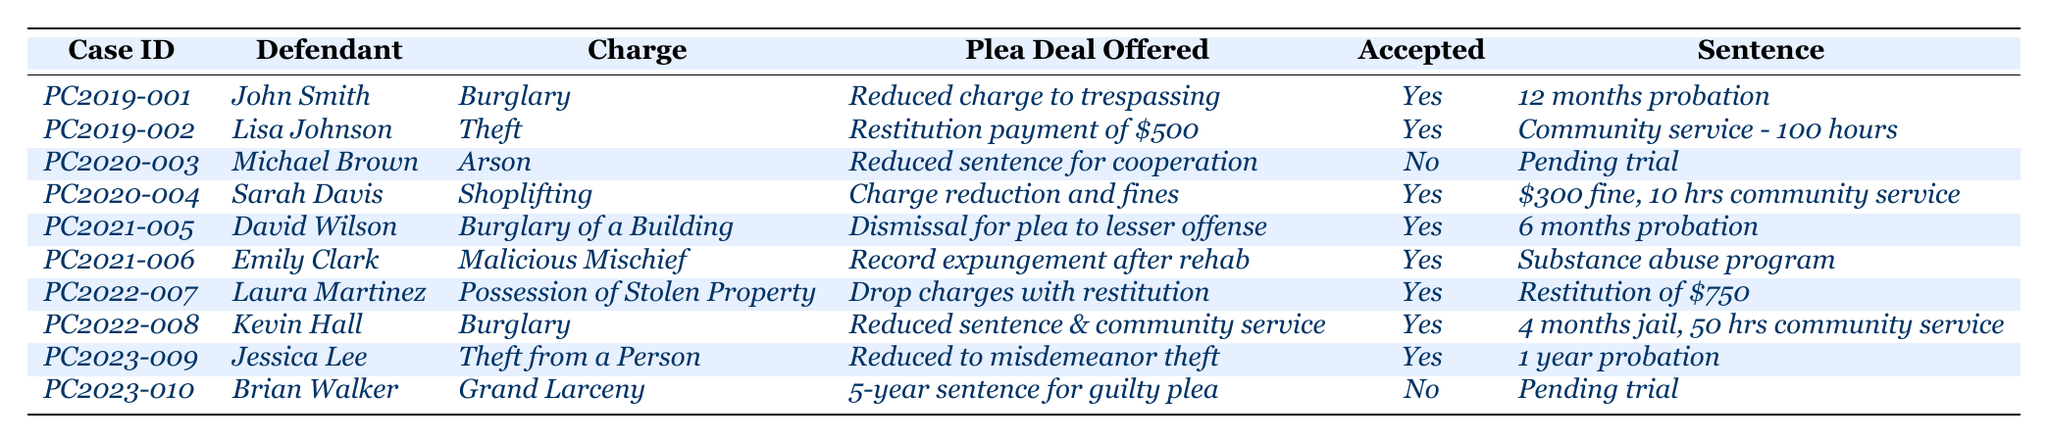What was the plea deal offered to John Smith? The table shows that John Smith was offered a plea deal to have his burglary charge reduced to trespassing.
Answer: Reduced charge to trespassing How many defendants accepted their plea deals in 2020? In 2020, there were two cases: Michael Brown did not accept his plea deal, while Sarah Davis did. Thus, the count of accepted plea deals is 1.
Answer: 1 Which defendant was offered restitution payment? Lisa Johnson was offered a plea deal involving a restitution payment of $500 for her theft charge.
Answer: Lisa Johnson What sentence did Emily Clark receive? The table indicates that Emily Clark, who was charged with malicious mischief and accepted her plea deal, was sentenced to a substance abuse program.
Answer: Substance abuse program What is the total number of plea deals accepted from 2019 to 2023? By counting the accepted plea deals for each year in the data: 2019 (2), 2020 (1), 2021 (3), 2022 (2), and 2023 (1), the total is 9.
Answer: 9 Did Jessica Lee's plea deal involve a reduced charge? Yes, Jessica Lee's plea deal involved reducing her charges from theft from a person to a misdemeanor theft.
Answer: Yes How many defendants faced charges related to burglary? The table lists three defendants (John Smith, David Wilson, and Kevin Hall) who were charged with burglary-related offenses across the years.
Answer: 3 What sentence did Brian Walker face if he did not accept his plea deal? Brian Walker's case is still pending trial, indicating that he has not yet been sentenced.
Answer: Pending trial Which plea deal offered included community service as a sentence? Lisa Johnson was given a plea deal involving community service, where she was sentenced to complete 100 hours of community service.
Answer: Lisa Johnson What was the average sentence length for accepted plea deals in 2021? The sentences for accepted plea deals in 2021 are: 6 months probation and a substance abuse program which does not have a quantifiable length. However, considering only the 6 months probation, you calculate the average by dividing 6 by 1, resulting in 6 months.
Answer: 6 months 